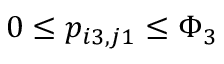Convert formula to latex. <formula><loc_0><loc_0><loc_500><loc_500>0 \leq p _ { i 3 , j 1 } \leq \Phi _ { 3 }</formula> 